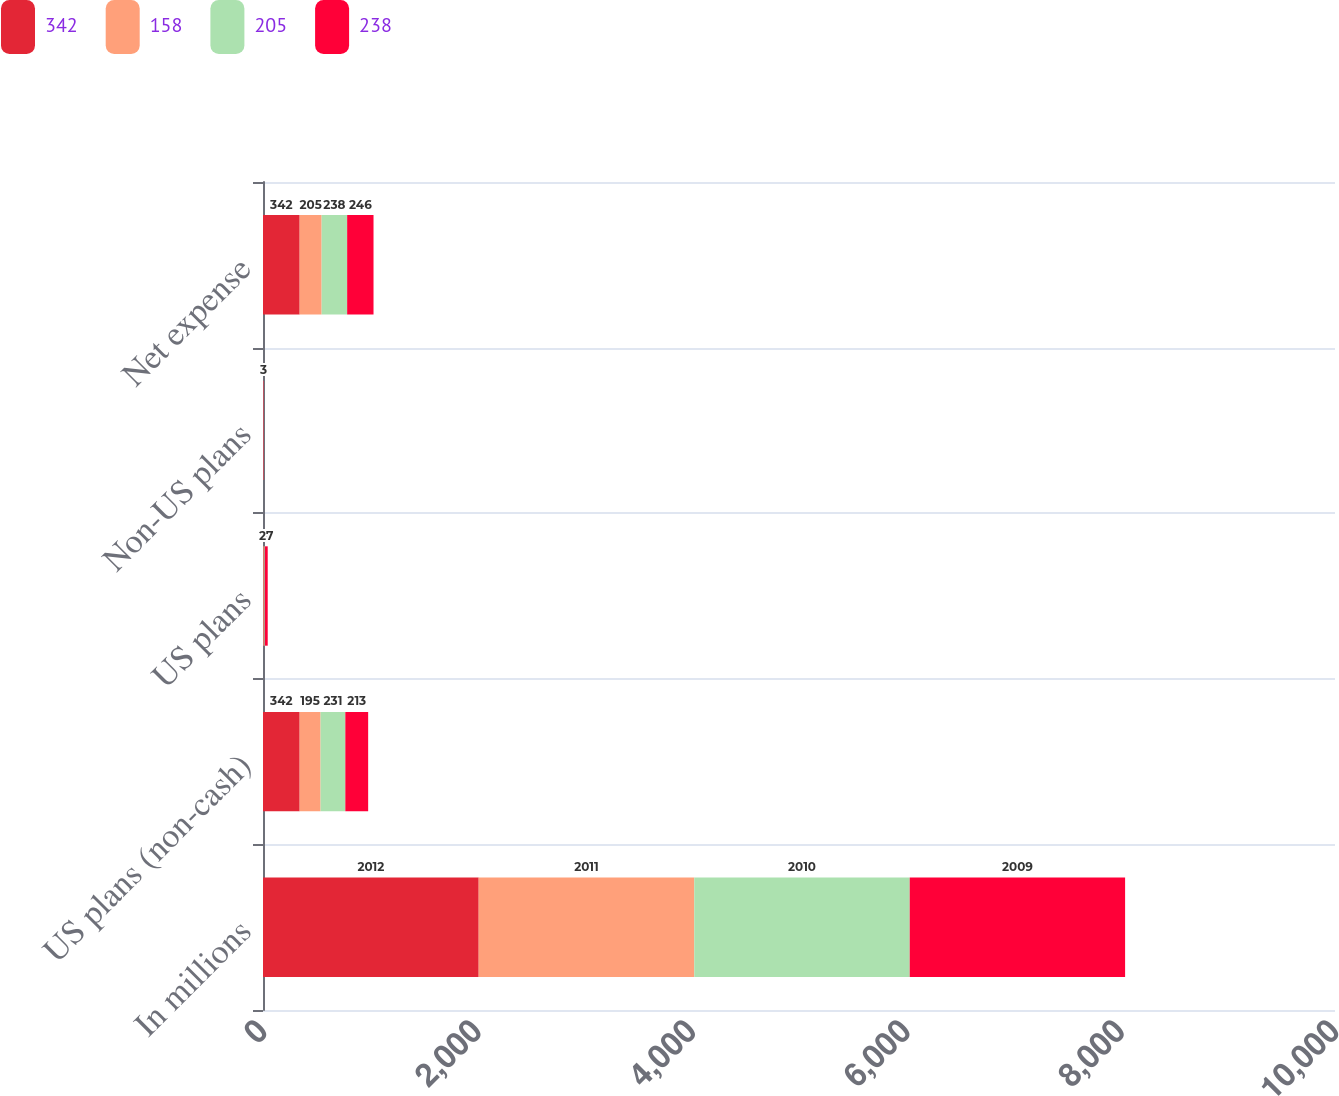Convert chart to OTSL. <chart><loc_0><loc_0><loc_500><loc_500><stacked_bar_chart><ecel><fcel>In millions<fcel>US plans (non-cash)<fcel>US plans<fcel>Non-US plans<fcel>Net expense<nl><fcel>342<fcel>2012<fcel>342<fcel>4<fcel>1<fcel>342<nl><fcel>158<fcel>2011<fcel>195<fcel>7<fcel>2<fcel>205<nl><fcel>205<fcel>2010<fcel>231<fcel>6<fcel>1<fcel>238<nl><fcel>238<fcel>2009<fcel>213<fcel>27<fcel>3<fcel>246<nl></chart> 